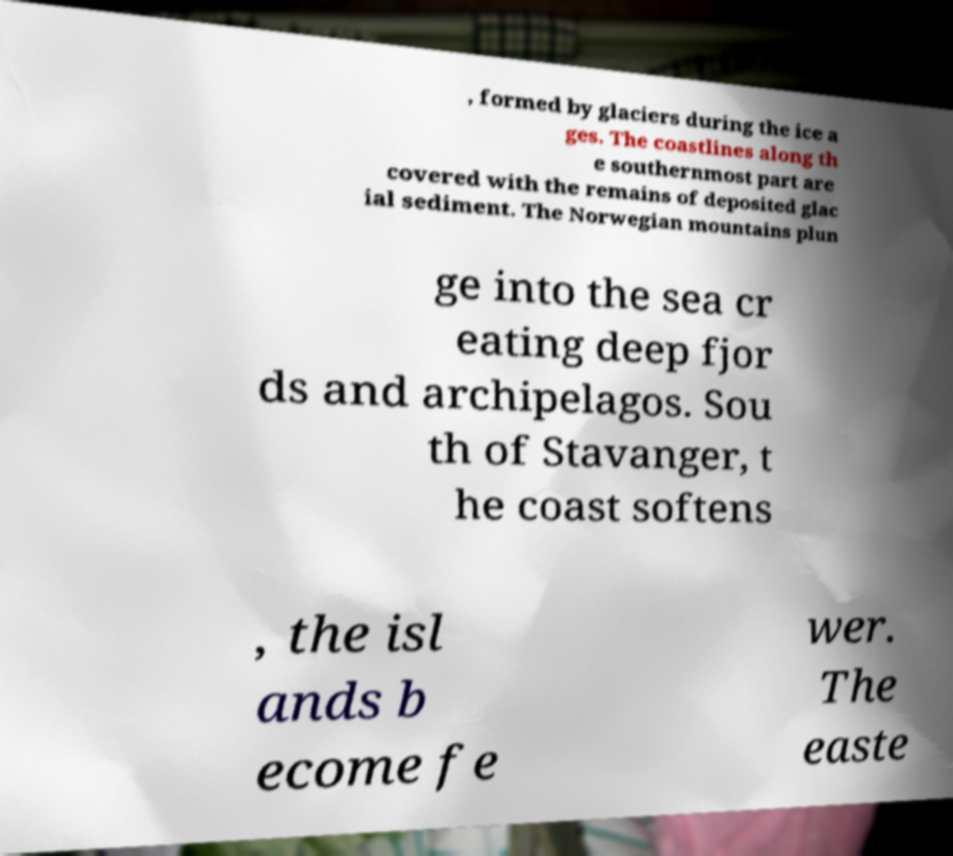There's text embedded in this image that I need extracted. Can you transcribe it verbatim? , formed by glaciers during the ice a ges. The coastlines along th e southernmost part are covered with the remains of deposited glac ial sediment. The Norwegian mountains plun ge into the sea cr eating deep fjor ds and archipelagos. Sou th of Stavanger, t he coast softens , the isl ands b ecome fe wer. The easte 